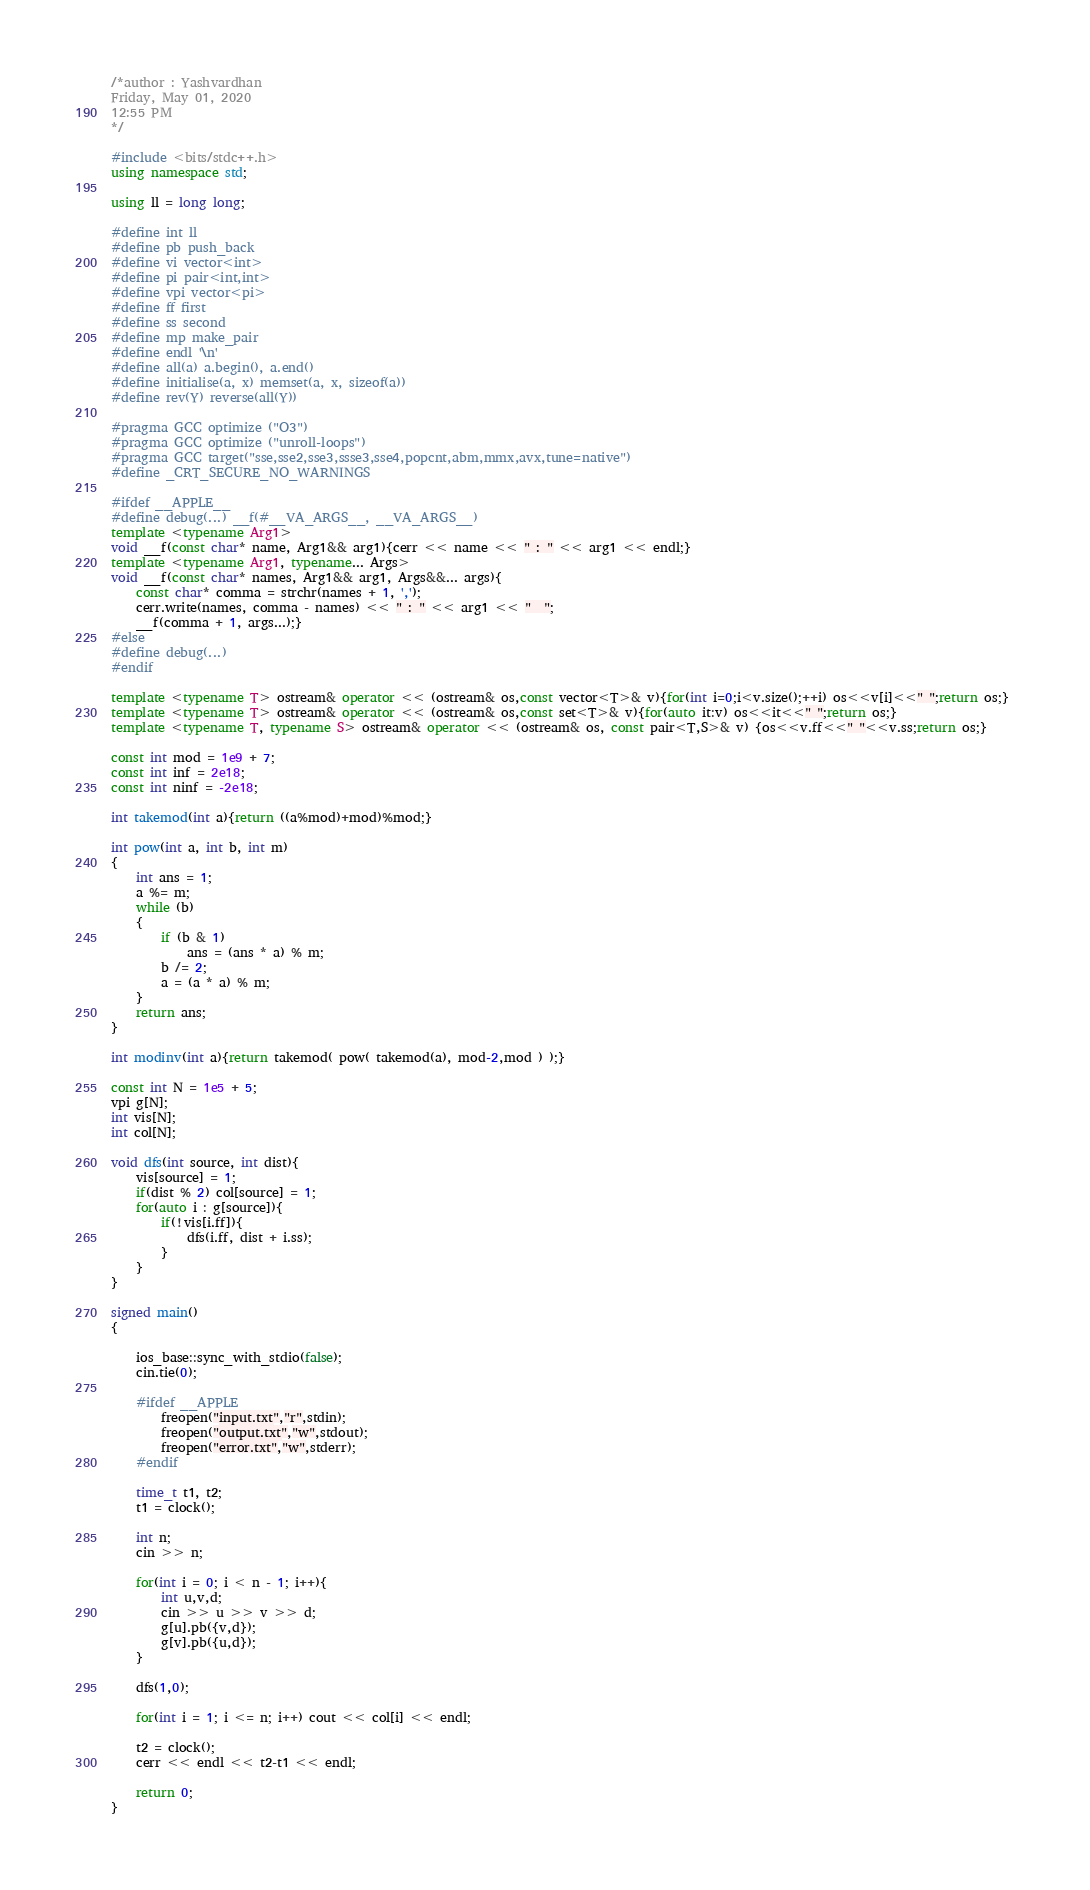<code> <loc_0><loc_0><loc_500><loc_500><_C++_>/*author : Yashvardhan
Friday, May 01, 2020
12:55 PM
*/

#include <bits/stdc++.h>
using namespace std;

using ll = long long;

#define int ll
#define pb push_back
#define vi vector<int>
#define pi pair<int,int>
#define vpi vector<pi>
#define ff first
#define ss second
#define mp make_pair
#define endl '\n'
#define all(a) a.begin(), a.end()
#define initialise(a, x) memset(a, x, sizeof(a))
#define rev(Y) reverse(all(Y))

#pragma GCC optimize ("O3")
#pragma GCC optimize ("unroll-loops")
#pragma GCC target("sse,sse2,sse3,ssse3,sse4,popcnt,abm,mmx,avx,tune=native")
#define _CRT_SECURE_NO_WARNINGS

#ifdef __APPLE__
#define debug(...) __f(#__VA_ARGS__, __VA_ARGS__)
template <typename Arg1>
void __f(const char* name, Arg1&& arg1){cerr << name << " : " << arg1 << endl;}
template <typename Arg1, typename... Args>
void __f(const char* names, Arg1&& arg1, Args&&... args){
	const char* comma = strchr(names + 1, ',');
	cerr.write(names, comma - names) << " : " << arg1 << "  ";
	__f(comma + 1, args...);}
#else
#define debug(...)
#endif

template <typename T> ostream& operator << (ostream& os,const vector<T>& v){for(int i=0;i<v.size();++i) os<<v[i]<<" ";return os;} 
template <typename T> ostream& operator << (ostream& os,const set<T>& v){for(auto it:v) os<<it<<" ";return os;} 
template <typename T, typename S> ostream& operator << (ostream& os, const pair<T,S>& v) {os<<v.ff<<" "<<v.ss;return os;}

const int mod = 1e9 + 7;
const int inf = 2e18;
const int ninf = -2e18;

int takemod(int a){return ((a%mod)+mod)%mod;}

int pow(int a, int b, int m)
{
	int ans = 1;
	a %= m;
	while (b)
	{
		if (b & 1)
			ans = (ans * a) % m;
		b /= 2;
		a = (a * a) % m;
	}
	return ans;
}

int modinv(int a){return takemod( pow( takemod(a), mod-2,mod ) );}

const int N = 1e5 + 5;
vpi g[N];
int vis[N];
int col[N];

void dfs(int source, int dist){
	vis[source] = 1;
	if(dist % 2) col[source] = 1;
	for(auto i : g[source]){
		if(!vis[i.ff]){
			dfs(i.ff, dist + i.ss);
		}
	}
}

signed main()
{

	ios_base::sync_with_stdio(false);
	cin.tie(0);

	#ifdef __APPLE__
		freopen("input.txt","r",stdin);
		freopen("output.txt","w",stdout);
		freopen("error.txt","w",stderr);
	#endif

	time_t t1, t2;
	t1 = clock();
	
	int n;
	cin >> n;

	for(int i = 0; i < n - 1; i++){
		int u,v,d;
		cin >> u >> v >> d;
		g[u].pb({v,d});
		g[v].pb({u,d});
	}

	dfs(1,0);

	for(int i = 1; i <= n; i++) cout << col[i] << endl;

	t2 = clock();
	cerr << endl << t2-t1 << endl;
	
	return 0;
}

</code> 